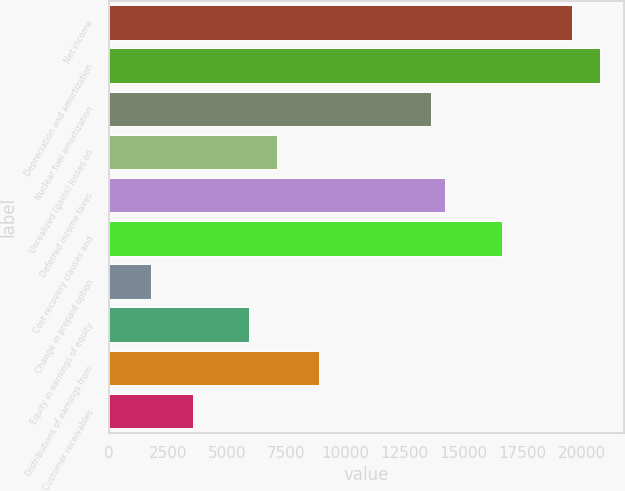Convert chart. <chart><loc_0><loc_0><loc_500><loc_500><bar_chart><fcel>Net income<fcel>Depreciation and amortization<fcel>Nuclear fuel amortization<fcel>Unrealized (gains) losses on<fcel>Deferred income taxes<fcel>Cost recovery clauses and<fcel>Change in prepaid option<fcel>Equity in earnings of equity<fcel>Distributions of earnings from<fcel>Customer receivables<nl><fcel>19574<fcel>20760<fcel>13644<fcel>7121<fcel>14237<fcel>16609<fcel>1784<fcel>5935<fcel>8900<fcel>3563<nl></chart> 